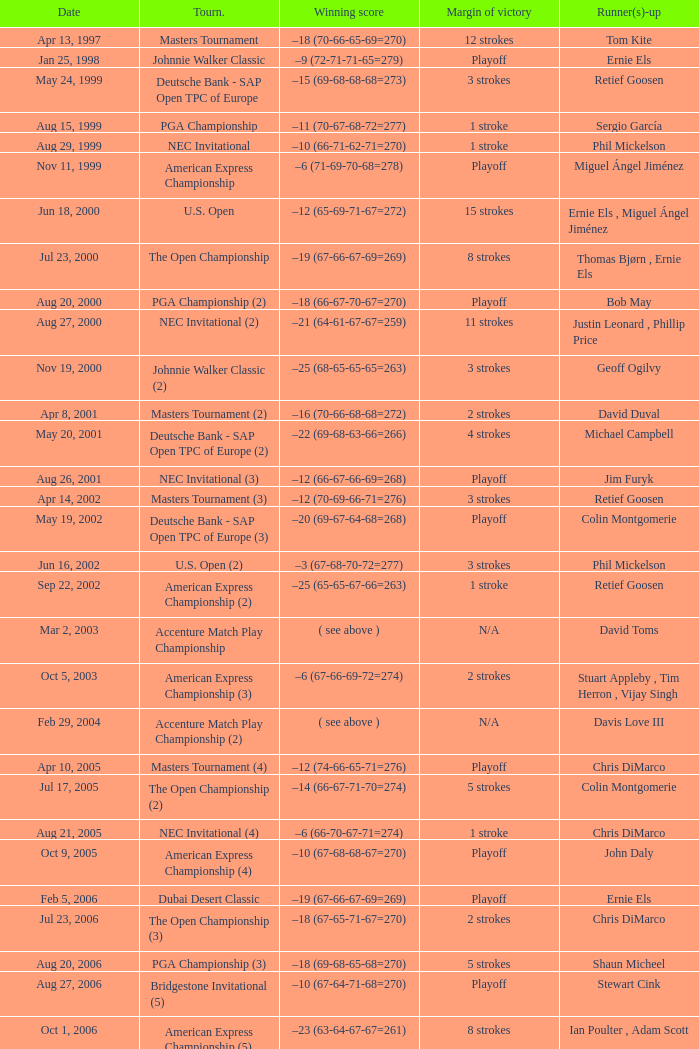Who is Runner(s)-up that has a Date of may 24, 1999? Retief Goosen. 